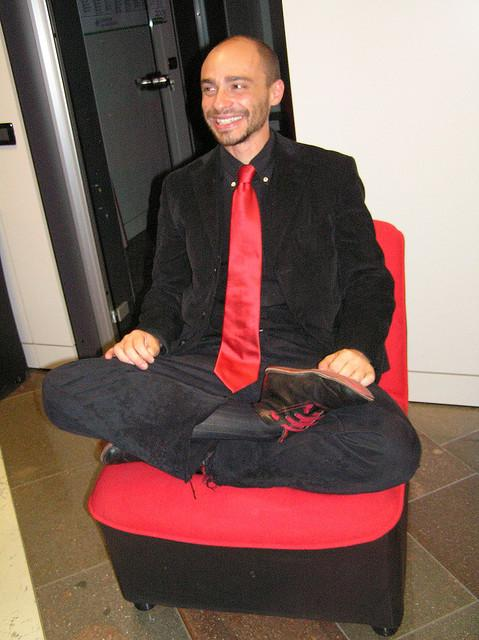What is the man wearing?

Choices:
A) boa
B) crown
C) armor
D) tie tie 